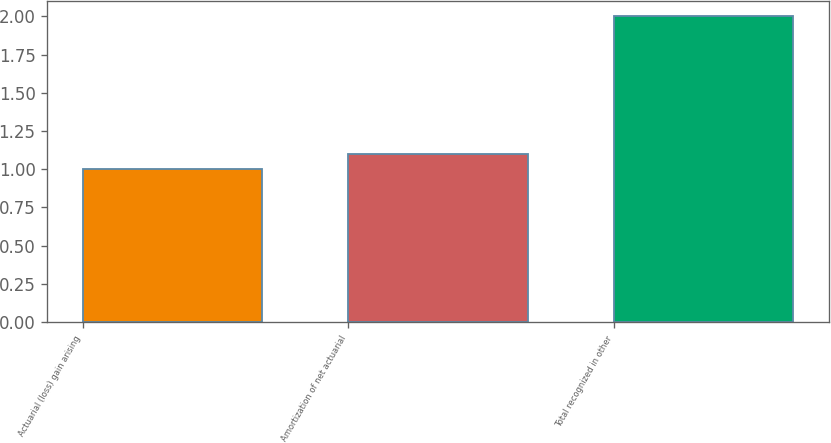Convert chart to OTSL. <chart><loc_0><loc_0><loc_500><loc_500><bar_chart><fcel>Actuarial (loss) gain arising<fcel>Amortization of net actuarial<fcel>Total recognized in other<nl><fcel>1<fcel>1.1<fcel>2<nl></chart> 